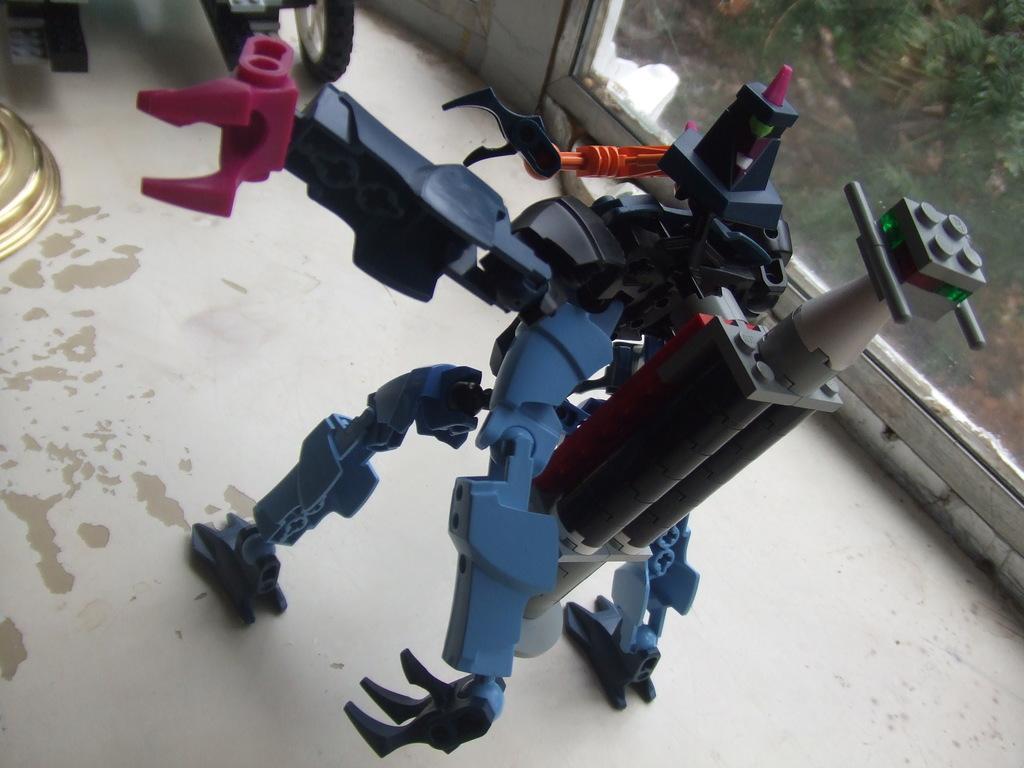Describe this image in one or two sentences. Here we can see a toy on the floor. In the background we can see a glass. From the glass we can see plants. 